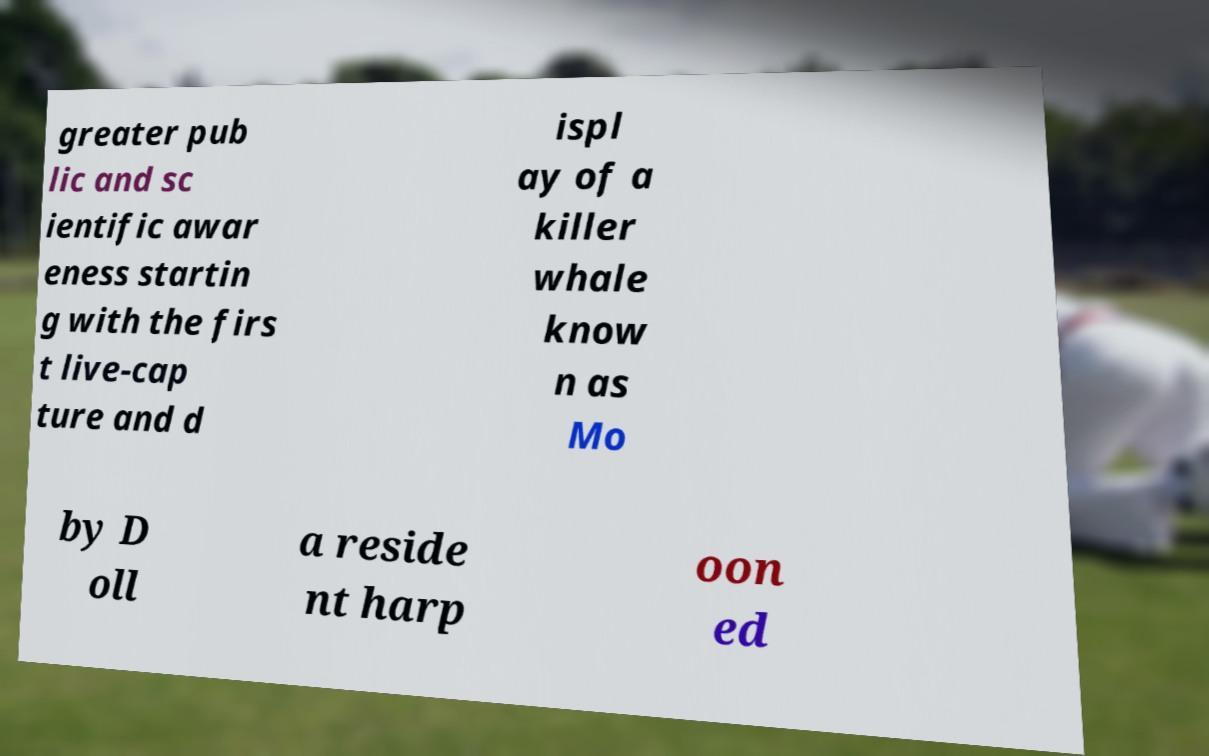Please identify and transcribe the text found in this image. greater pub lic and sc ientific awar eness startin g with the firs t live-cap ture and d ispl ay of a killer whale know n as Mo by D oll a reside nt harp oon ed 